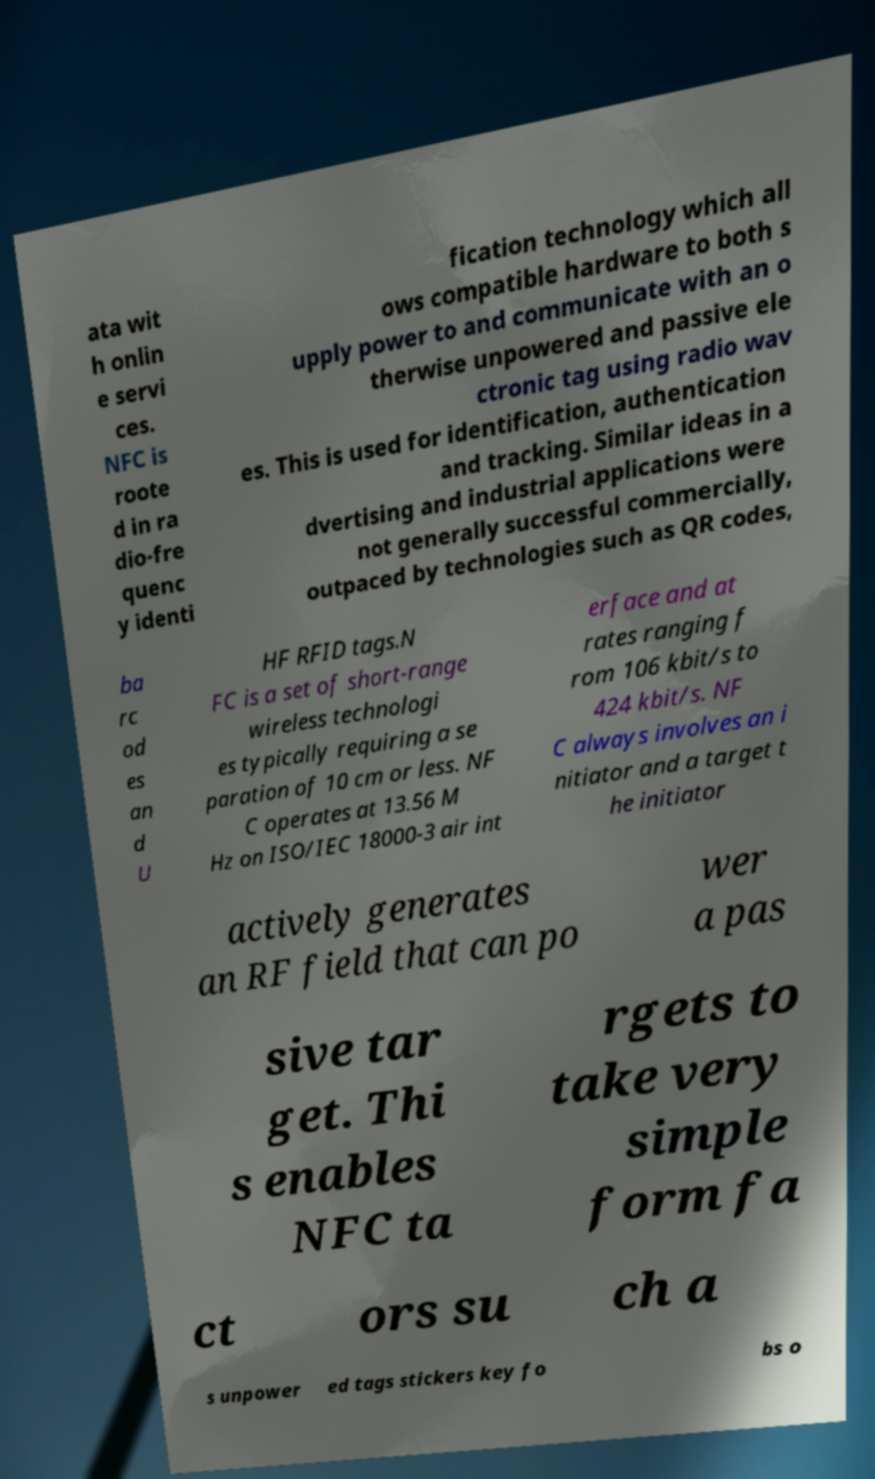Please identify and transcribe the text found in this image. ata wit h onlin e servi ces. NFC is roote d in ra dio-fre quenc y identi fication technology which all ows compatible hardware to both s upply power to and communicate with an o therwise unpowered and passive ele ctronic tag using radio wav es. This is used for identification, authentication and tracking. Similar ideas in a dvertising and industrial applications were not generally successful commercially, outpaced by technologies such as QR codes, ba rc od es an d U HF RFID tags.N FC is a set of short-range wireless technologi es typically requiring a se paration of 10 cm or less. NF C operates at 13.56 M Hz on ISO/IEC 18000-3 air int erface and at rates ranging f rom 106 kbit/s to 424 kbit/s. NF C always involves an i nitiator and a target t he initiator actively generates an RF field that can po wer a pas sive tar get. Thi s enables NFC ta rgets to take very simple form fa ct ors su ch a s unpower ed tags stickers key fo bs o 